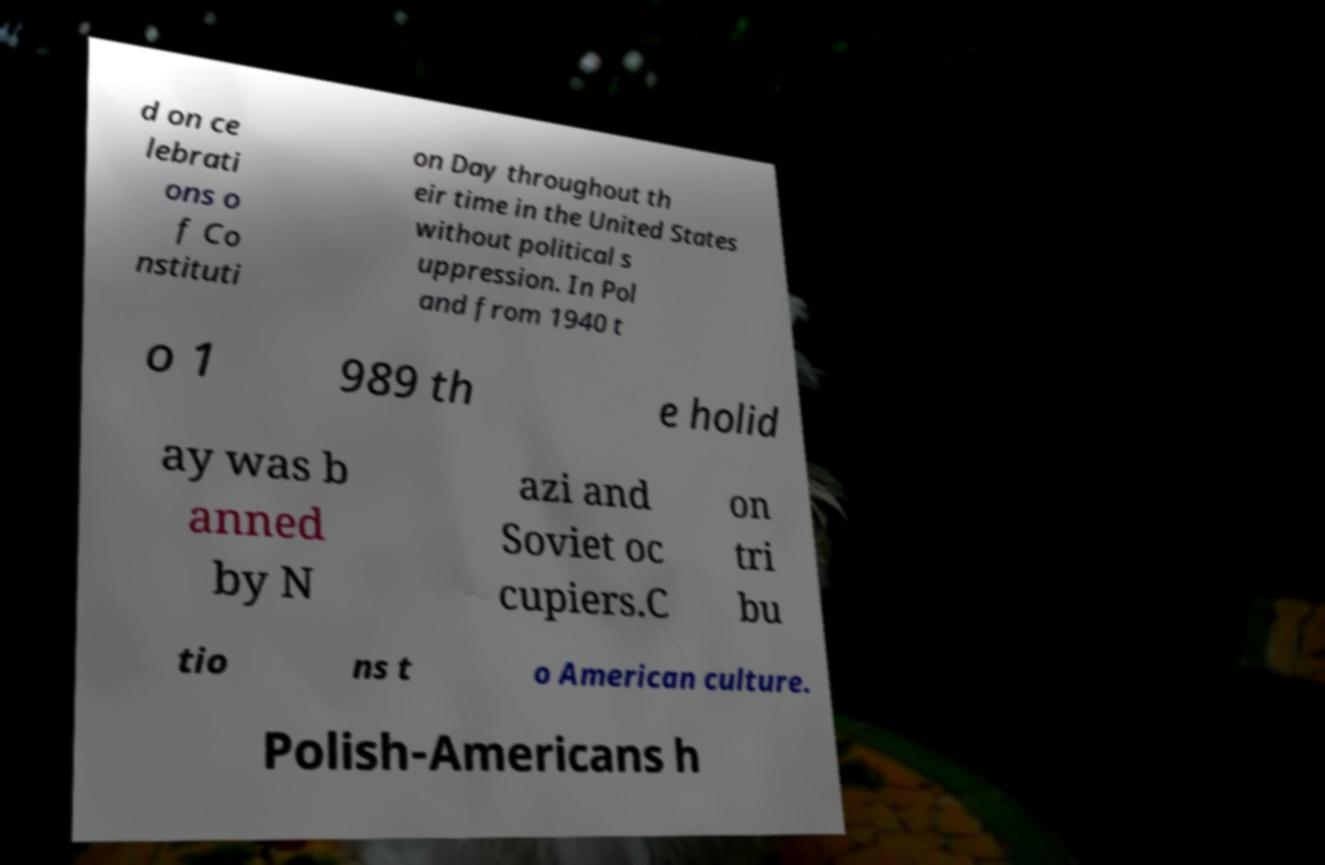Please identify and transcribe the text found in this image. d on ce lebrati ons o f Co nstituti on Day throughout th eir time in the United States without political s uppression. In Pol and from 1940 t o 1 989 th e holid ay was b anned by N azi and Soviet oc cupiers.C on tri bu tio ns t o American culture. Polish-Americans h 